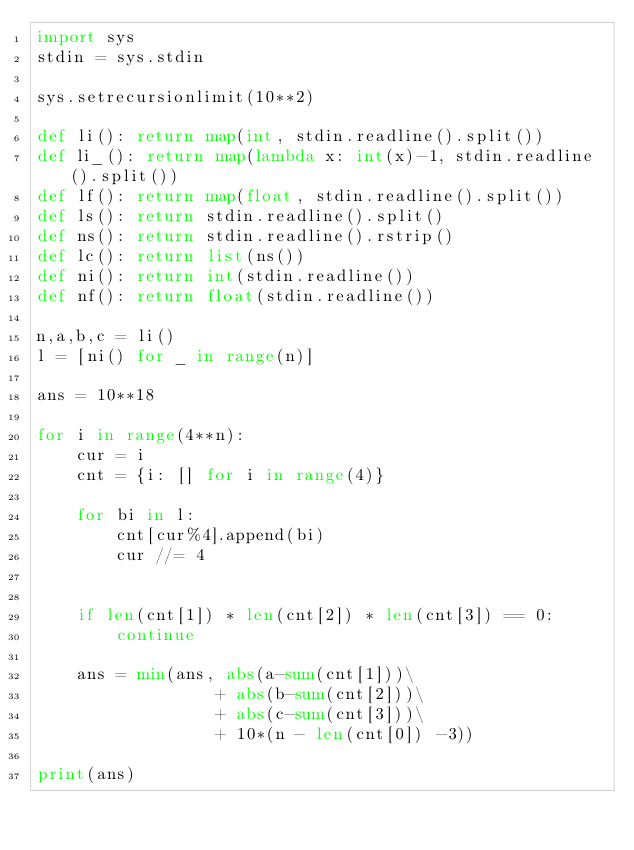Convert code to text. <code><loc_0><loc_0><loc_500><loc_500><_Python_>import sys
stdin = sys.stdin
 
sys.setrecursionlimit(10**2) 
 
def li(): return map(int, stdin.readline().split())
def li_(): return map(lambda x: int(x)-1, stdin.readline().split())
def lf(): return map(float, stdin.readline().split())
def ls(): return stdin.readline().split()
def ns(): return stdin.readline().rstrip()
def lc(): return list(ns())
def ni(): return int(stdin.readline())
def nf(): return float(stdin.readline())

n,a,b,c = li()
l = [ni() for _ in range(n)]

ans = 10**18

for i in range(4**n):
    cur = i
    cnt = {i: [] for i in range(4)}
    
    for bi in l:
        cnt[cur%4].append(bi)
        cur //= 4
    
    
    if len(cnt[1]) * len(cnt[2]) * len(cnt[3]) == 0:
        continue
    
    ans = min(ans, abs(a-sum(cnt[1]))\
                  + abs(b-sum(cnt[2]))\
                  + abs(c-sum(cnt[3]))\
                  + 10*(n - len(cnt[0]) -3))
    
print(ans)</code> 